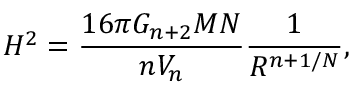Convert formula to latex. <formula><loc_0><loc_0><loc_500><loc_500>H ^ { 2 } = \frac { 1 6 \pi G _ { n + 2 } M N } { n V _ { n } } \frac { 1 } { R ^ { n + 1 / N } } ,</formula> 